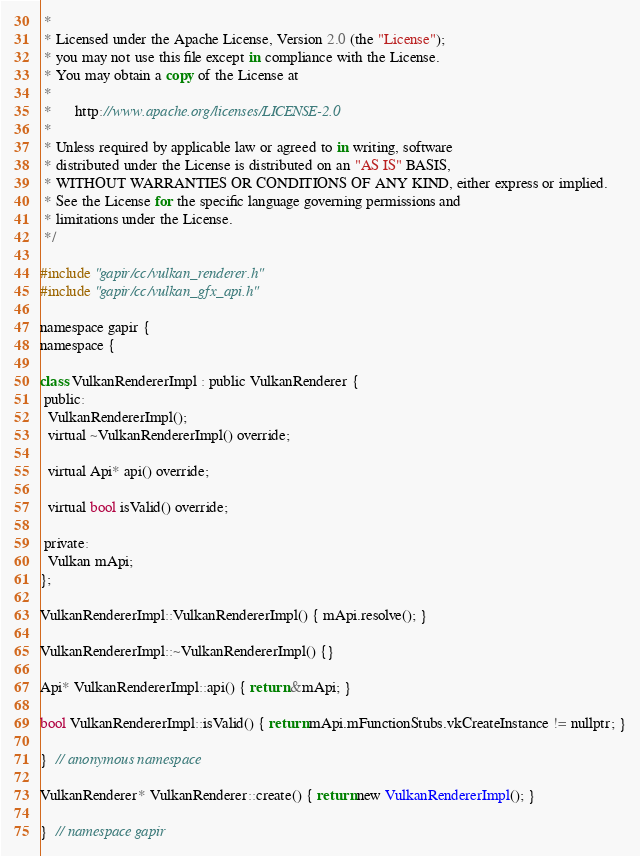<code> <loc_0><loc_0><loc_500><loc_500><_ObjectiveC_> *
 * Licensed under the Apache License, Version 2.0 (the "License");
 * you may not use this file except in compliance with the License.
 * You may obtain a copy of the License at
 *
 *      http://www.apache.org/licenses/LICENSE-2.0
 *
 * Unless required by applicable law or agreed to in writing, software
 * distributed under the License is distributed on an "AS IS" BASIS,
 * WITHOUT WARRANTIES OR CONDITIONS OF ANY KIND, either express or implied.
 * See the License for the specific language governing permissions and
 * limitations under the License.
 */

#include "gapir/cc/vulkan_renderer.h"
#include "gapir/cc/vulkan_gfx_api.h"

namespace gapir {
namespace {

class VulkanRendererImpl : public VulkanRenderer {
 public:
  VulkanRendererImpl();
  virtual ~VulkanRendererImpl() override;

  virtual Api* api() override;

  virtual bool isValid() override;

 private:
  Vulkan mApi;
};

VulkanRendererImpl::VulkanRendererImpl() { mApi.resolve(); }

VulkanRendererImpl::~VulkanRendererImpl() {}

Api* VulkanRendererImpl::api() { return &mApi; }

bool VulkanRendererImpl::isValid() { return mApi.mFunctionStubs.vkCreateInstance != nullptr; }

}  // anonymous namespace

VulkanRenderer* VulkanRenderer::create() { return new VulkanRendererImpl(); }

}  // namespace gapir
</code> 